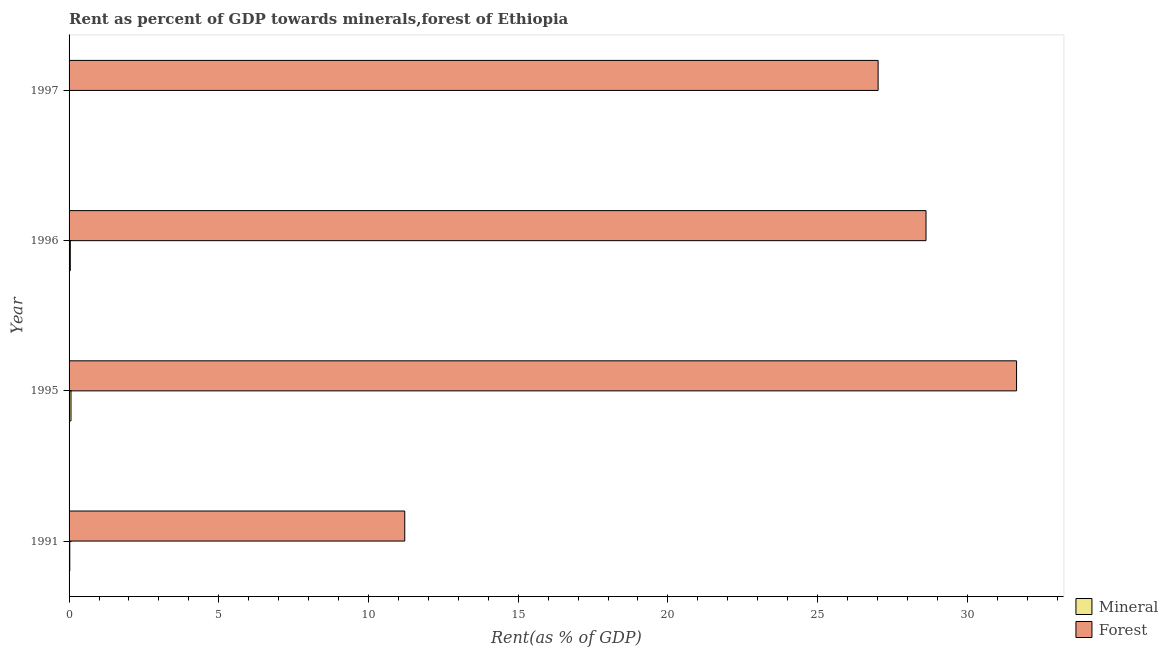How many groups of bars are there?
Offer a very short reply. 4. How many bars are there on the 1st tick from the top?
Offer a very short reply. 2. How many bars are there on the 1st tick from the bottom?
Offer a terse response. 2. What is the label of the 1st group of bars from the top?
Provide a succinct answer. 1997. What is the mineral rent in 1991?
Offer a terse response. 0.02. Across all years, what is the maximum mineral rent?
Offer a terse response. 0.06. Across all years, what is the minimum mineral rent?
Your answer should be very brief. 0. What is the total mineral rent in the graph?
Offer a very short reply. 0.13. What is the difference between the mineral rent in 1995 and that in 1996?
Your answer should be very brief. 0.02. What is the difference between the mineral rent in 1995 and the forest rent in 1997?
Offer a terse response. -26.96. What is the average mineral rent per year?
Your answer should be very brief. 0.03. In the year 1996, what is the difference between the mineral rent and forest rent?
Keep it short and to the point. -28.58. What is the ratio of the forest rent in 1996 to that in 1997?
Keep it short and to the point. 1.06. What is the difference between the highest and the second highest forest rent?
Provide a succinct answer. 3.02. What is the difference between the highest and the lowest mineral rent?
Give a very brief answer. 0.06. In how many years, is the mineral rent greater than the average mineral rent taken over all years?
Your response must be concise. 2. What does the 2nd bar from the top in 1997 represents?
Keep it short and to the point. Mineral. What does the 2nd bar from the bottom in 1997 represents?
Your response must be concise. Forest. How many bars are there?
Give a very brief answer. 8. Are the values on the major ticks of X-axis written in scientific E-notation?
Keep it short and to the point. No. How many legend labels are there?
Your answer should be compact. 2. What is the title of the graph?
Offer a very short reply. Rent as percent of GDP towards minerals,forest of Ethiopia. What is the label or title of the X-axis?
Give a very brief answer. Rent(as % of GDP). What is the label or title of the Y-axis?
Keep it short and to the point. Year. What is the Rent(as % of GDP) of Mineral in 1991?
Keep it short and to the point. 0.02. What is the Rent(as % of GDP) of Forest in 1991?
Your answer should be compact. 11.21. What is the Rent(as % of GDP) of Mineral in 1995?
Ensure brevity in your answer.  0.06. What is the Rent(as % of GDP) in Forest in 1995?
Your answer should be compact. 31.64. What is the Rent(as % of GDP) of Mineral in 1996?
Give a very brief answer. 0.04. What is the Rent(as % of GDP) in Forest in 1996?
Keep it short and to the point. 28.62. What is the Rent(as % of GDP) in Mineral in 1997?
Ensure brevity in your answer.  0. What is the Rent(as % of GDP) of Forest in 1997?
Make the answer very short. 27.02. Across all years, what is the maximum Rent(as % of GDP) of Mineral?
Keep it short and to the point. 0.06. Across all years, what is the maximum Rent(as % of GDP) in Forest?
Offer a terse response. 31.64. Across all years, what is the minimum Rent(as % of GDP) in Mineral?
Your answer should be very brief. 0. Across all years, what is the minimum Rent(as % of GDP) of Forest?
Keep it short and to the point. 11.21. What is the total Rent(as % of GDP) of Mineral in the graph?
Keep it short and to the point. 0.13. What is the total Rent(as % of GDP) of Forest in the graph?
Your answer should be very brief. 98.5. What is the difference between the Rent(as % of GDP) of Mineral in 1991 and that in 1995?
Offer a very short reply. -0.04. What is the difference between the Rent(as % of GDP) in Forest in 1991 and that in 1995?
Give a very brief answer. -20.43. What is the difference between the Rent(as % of GDP) of Mineral in 1991 and that in 1996?
Give a very brief answer. -0.02. What is the difference between the Rent(as % of GDP) of Forest in 1991 and that in 1996?
Your answer should be very brief. -17.41. What is the difference between the Rent(as % of GDP) in Mineral in 1991 and that in 1997?
Provide a succinct answer. 0.02. What is the difference between the Rent(as % of GDP) of Forest in 1991 and that in 1997?
Offer a terse response. -15.81. What is the difference between the Rent(as % of GDP) in Mineral in 1995 and that in 1996?
Your answer should be very brief. 0.02. What is the difference between the Rent(as % of GDP) of Forest in 1995 and that in 1996?
Keep it short and to the point. 3.02. What is the difference between the Rent(as % of GDP) of Mineral in 1995 and that in 1997?
Your answer should be compact. 0.06. What is the difference between the Rent(as % of GDP) of Forest in 1995 and that in 1997?
Keep it short and to the point. 4.62. What is the difference between the Rent(as % of GDP) in Mineral in 1996 and that in 1997?
Your answer should be very brief. 0.04. What is the difference between the Rent(as % of GDP) of Forest in 1996 and that in 1997?
Give a very brief answer. 1.6. What is the difference between the Rent(as % of GDP) in Mineral in 1991 and the Rent(as % of GDP) in Forest in 1995?
Offer a very short reply. -31.62. What is the difference between the Rent(as % of GDP) of Mineral in 1991 and the Rent(as % of GDP) of Forest in 1996?
Keep it short and to the point. -28.6. What is the difference between the Rent(as % of GDP) of Mineral in 1991 and the Rent(as % of GDP) of Forest in 1997?
Keep it short and to the point. -27. What is the difference between the Rent(as % of GDP) in Mineral in 1995 and the Rent(as % of GDP) in Forest in 1996?
Provide a short and direct response. -28.56. What is the difference between the Rent(as % of GDP) of Mineral in 1995 and the Rent(as % of GDP) of Forest in 1997?
Keep it short and to the point. -26.96. What is the difference between the Rent(as % of GDP) of Mineral in 1996 and the Rent(as % of GDP) of Forest in 1997?
Offer a very short reply. -26.98. What is the average Rent(as % of GDP) in Mineral per year?
Offer a terse response. 0.03. What is the average Rent(as % of GDP) in Forest per year?
Offer a very short reply. 24.62. In the year 1991, what is the difference between the Rent(as % of GDP) in Mineral and Rent(as % of GDP) in Forest?
Provide a succinct answer. -11.19. In the year 1995, what is the difference between the Rent(as % of GDP) of Mineral and Rent(as % of GDP) of Forest?
Make the answer very short. -31.58. In the year 1996, what is the difference between the Rent(as % of GDP) in Mineral and Rent(as % of GDP) in Forest?
Your answer should be compact. -28.58. In the year 1997, what is the difference between the Rent(as % of GDP) of Mineral and Rent(as % of GDP) of Forest?
Your answer should be compact. -27.02. What is the ratio of the Rent(as % of GDP) of Mineral in 1991 to that in 1995?
Ensure brevity in your answer.  0.37. What is the ratio of the Rent(as % of GDP) of Forest in 1991 to that in 1995?
Provide a short and direct response. 0.35. What is the ratio of the Rent(as % of GDP) in Mineral in 1991 to that in 1996?
Offer a terse response. 0.58. What is the ratio of the Rent(as % of GDP) of Forest in 1991 to that in 1996?
Keep it short and to the point. 0.39. What is the ratio of the Rent(as % of GDP) of Mineral in 1991 to that in 1997?
Your response must be concise. 5.65. What is the ratio of the Rent(as % of GDP) in Forest in 1991 to that in 1997?
Your response must be concise. 0.41. What is the ratio of the Rent(as % of GDP) of Mineral in 1995 to that in 1996?
Your answer should be very brief. 1.54. What is the ratio of the Rent(as % of GDP) of Forest in 1995 to that in 1996?
Make the answer very short. 1.11. What is the ratio of the Rent(as % of GDP) of Mineral in 1995 to that in 1997?
Keep it short and to the point. 15.13. What is the ratio of the Rent(as % of GDP) of Forest in 1995 to that in 1997?
Keep it short and to the point. 1.17. What is the ratio of the Rent(as % of GDP) in Mineral in 1996 to that in 1997?
Offer a terse response. 9.8. What is the ratio of the Rent(as % of GDP) of Forest in 1996 to that in 1997?
Keep it short and to the point. 1.06. What is the difference between the highest and the second highest Rent(as % of GDP) in Mineral?
Offer a terse response. 0.02. What is the difference between the highest and the second highest Rent(as % of GDP) of Forest?
Provide a succinct answer. 3.02. What is the difference between the highest and the lowest Rent(as % of GDP) in Mineral?
Ensure brevity in your answer.  0.06. What is the difference between the highest and the lowest Rent(as % of GDP) of Forest?
Offer a very short reply. 20.43. 